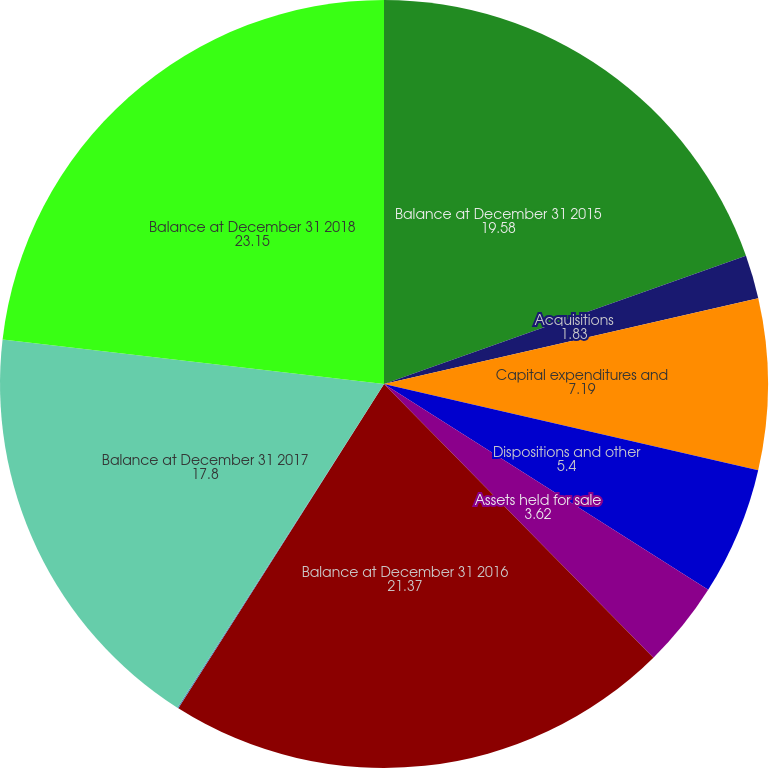Convert chart. <chart><loc_0><loc_0><loc_500><loc_500><pie_chart><fcel>Balance at December 31 2015<fcel>Acquisitions<fcel>Capital expenditures and<fcel>Dispositions and other<fcel>Assets held for sale<fcel>Balance at December 31 2016<fcel>Impairments<fcel>Balance at December 31 2017<fcel>Balance at December 31 2018<nl><fcel>19.58%<fcel>1.83%<fcel>7.19%<fcel>5.4%<fcel>3.62%<fcel>21.37%<fcel>0.05%<fcel>17.8%<fcel>23.15%<nl></chart> 